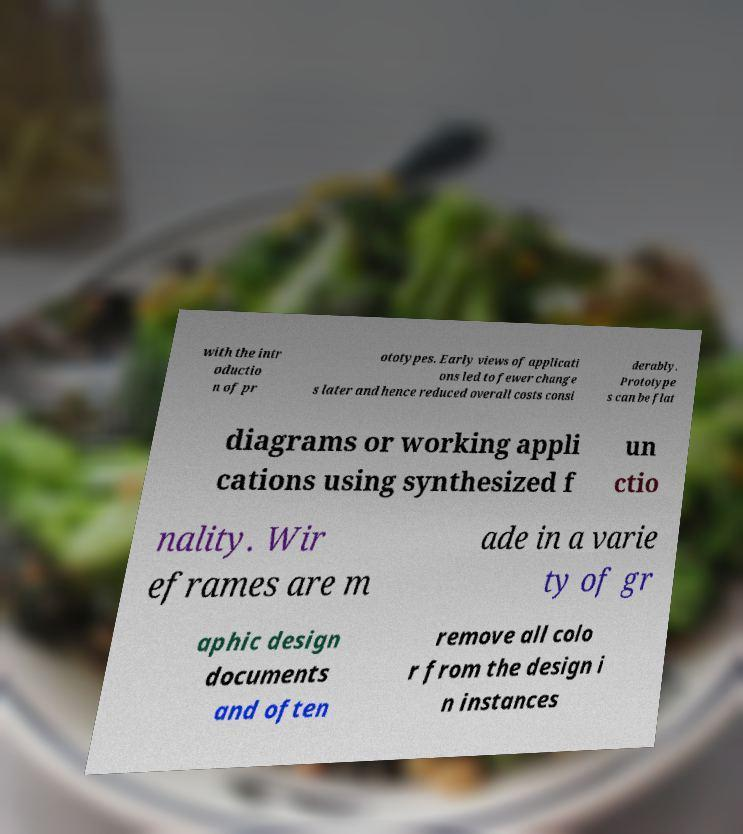Could you assist in decoding the text presented in this image and type it out clearly? with the intr oductio n of pr ototypes. Early views of applicati ons led to fewer change s later and hence reduced overall costs consi derably. Prototype s can be flat diagrams or working appli cations using synthesized f un ctio nality. Wir eframes are m ade in a varie ty of gr aphic design documents and often remove all colo r from the design i n instances 